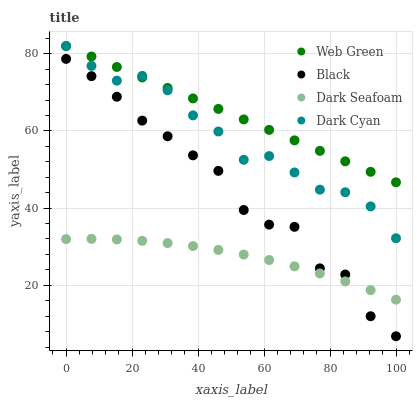Does Dark Seafoam have the minimum area under the curve?
Answer yes or no. Yes. Does Web Green have the maximum area under the curve?
Answer yes or no. Yes. Does Black have the minimum area under the curve?
Answer yes or no. No. Does Black have the maximum area under the curve?
Answer yes or no. No. Is Web Green the smoothest?
Answer yes or no. Yes. Is Black the roughest?
Answer yes or no. Yes. Is Dark Seafoam the smoothest?
Answer yes or no. No. Is Dark Seafoam the roughest?
Answer yes or no. No. Does Black have the lowest value?
Answer yes or no. Yes. Does Dark Seafoam have the lowest value?
Answer yes or no. No. Does Web Green have the highest value?
Answer yes or no. Yes. Does Black have the highest value?
Answer yes or no. No. Is Dark Seafoam less than Web Green?
Answer yes or no. Yes. Is Web Green greater than Black?
Answer yes or no. Yes. Does Black intersect Dark Seafoam?
Answer yes or no. Yes. Is Black less than Dark Seafoam?
Answer yes or no. No. Is Black greater than Dark Seafoam?
Answer yes or no. No. Does Dark Seafoam intersect Web Green?
Answer yes or no. No. 